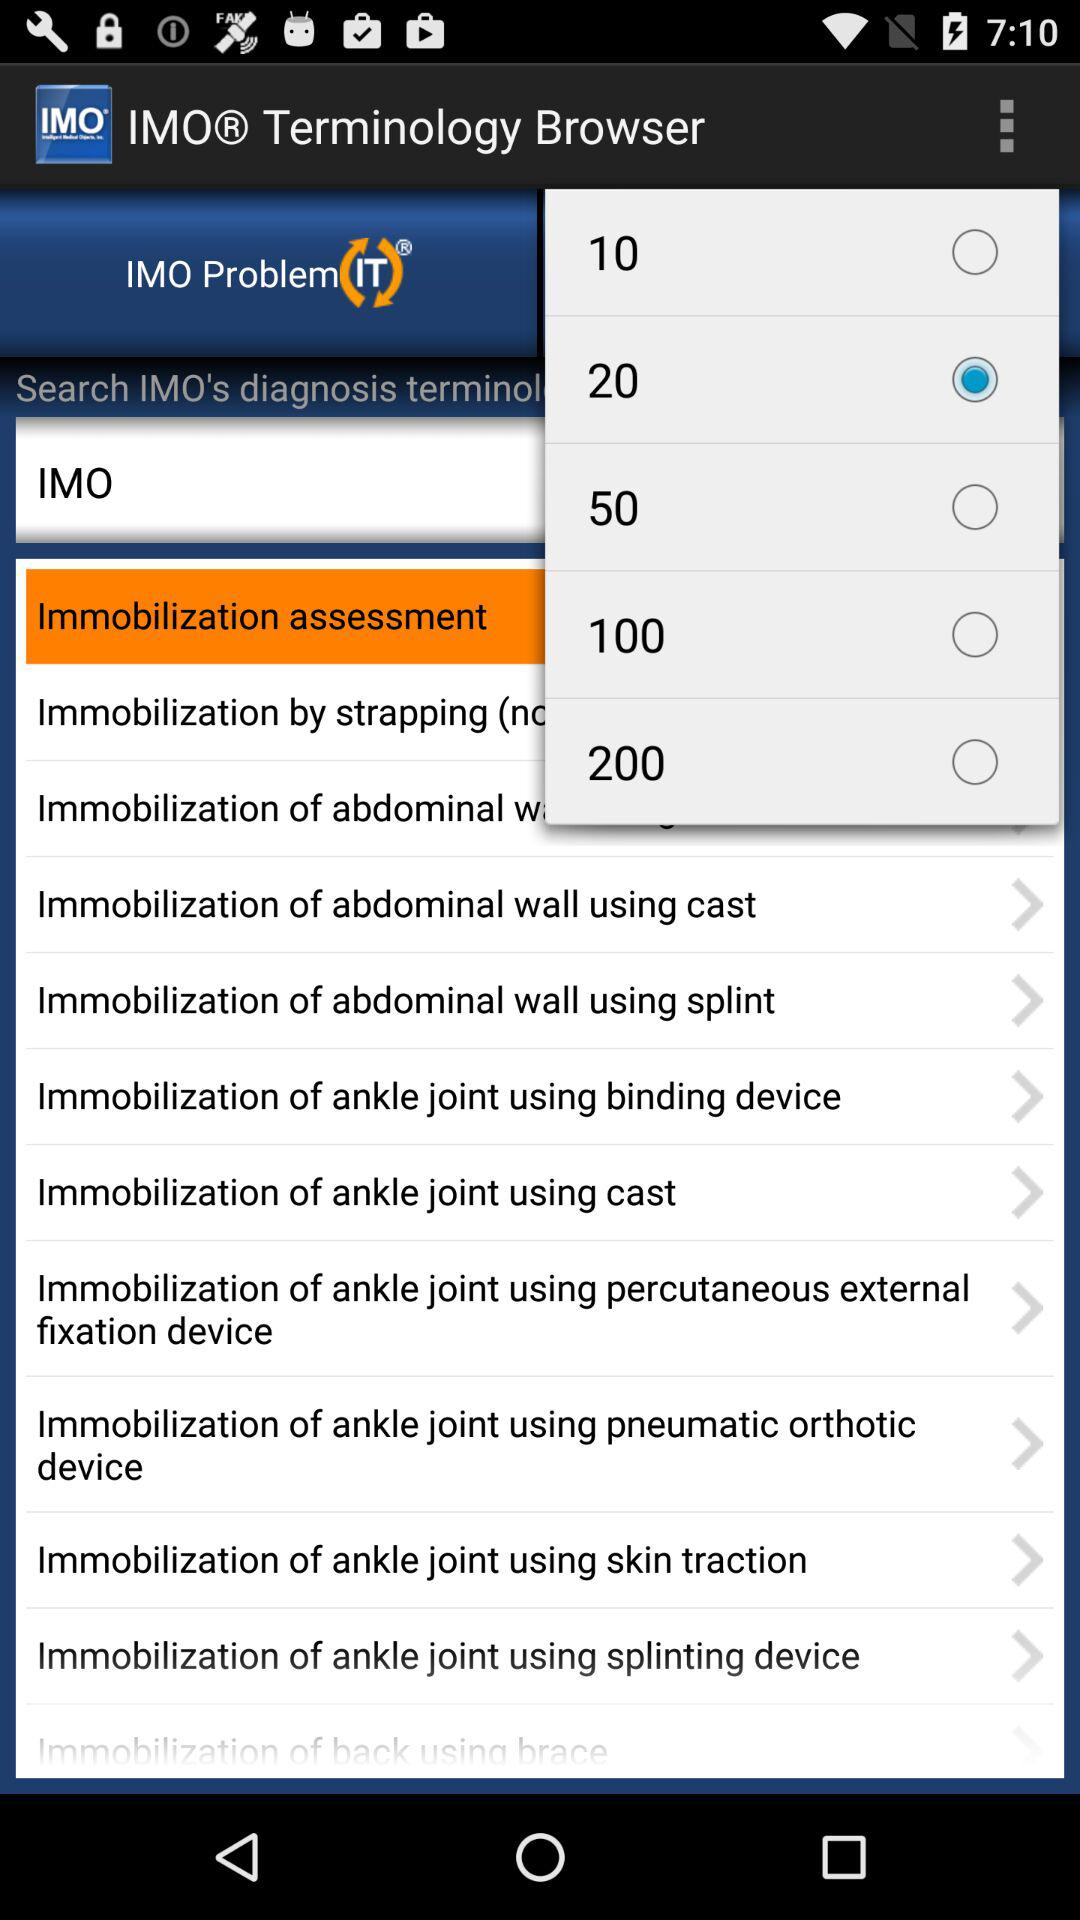Which value has been selected? The value that has been selected is 20. 